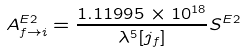<formula> <loc_0><loc_0><loc_500><loc_500>A ^ { E 2 } _ { f \rightarrow i } = \frac { 1 . 1 1 9 9 5 \times 1 0 ^ { 1 8 } } { \lambda ^ { 5 } [ j _ { f } ] } S ^ { E 2 }</formula> 